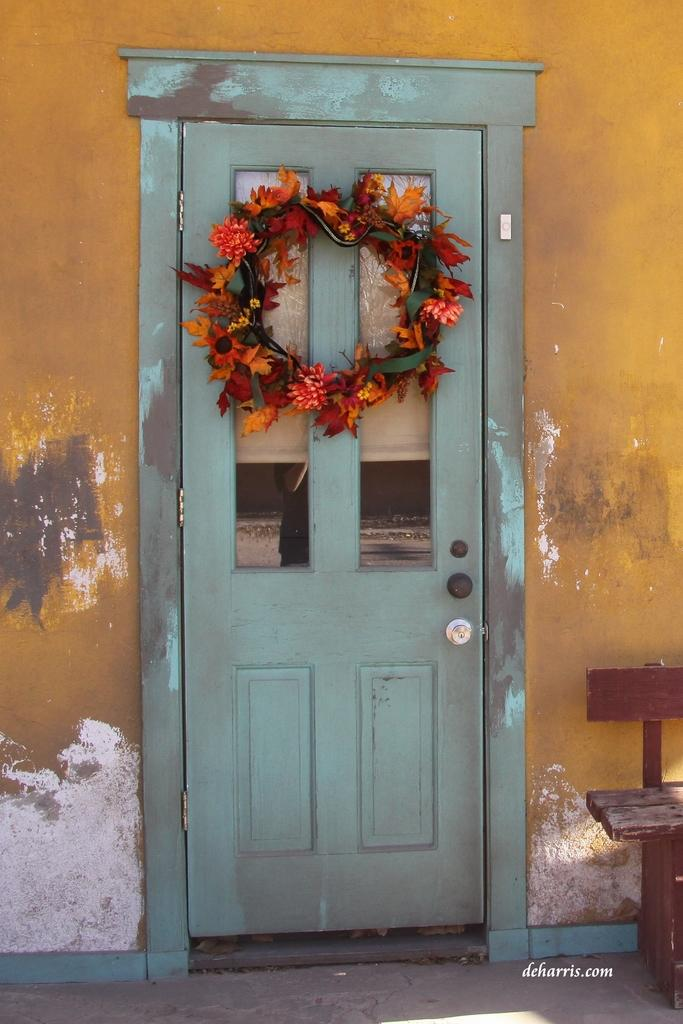What is the main object in the image? There is a door in the image. Can you describe the door? The door is blue. What else can be seen on the right side of the image? There is a bench on the right side of the image. How many pies are sitting on the bench in the image? There are no pies present in the image; only a door and a bench can be seen. 